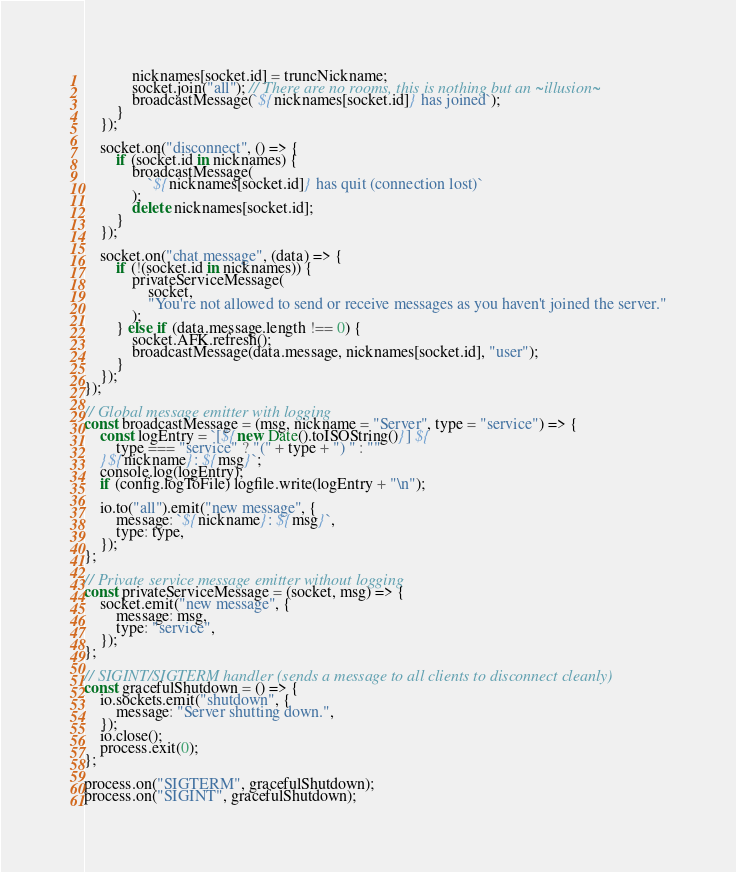Convert code to text. <code><loc_0><loc_0><loc_500><loc_500><_JavaScript_>            nicknames[socket.id] = truncNickname;
            socket.join("all"); // There are no rooms, this is nothing but an ~illusion~
            broadcastMessage(`${nicknames[socket.id]} has joined`);
        }
    });

    socket.on("disconnect", () => {
        if (socket.id in nicknames) {
            broadcastMessage(
                `${nicknames[socket.id]} has quit (connection lost)`
            );
            delete nicknames[socket.id];
        }
    });

    socket.on("chat message", (data) => {
        if (!(socket.id in nicknames)) {
            privateServiceMessage(
                socket,
                "You're not allowed to send or receive messages as you haven't joined the server."
            );
        } else if (data.message.length !== 0) {
            socket.AFK.refresh();
            broadcastMessage(data.message, nicknames[socket.id], "user");
        }
    });
});

// Global message emitter with logging
const broadcastMessage = (msg, nickname = "Server", type = "service") => {
    const logEntry = `[${new Date().toISOString()}] ${
        type === "service" ? "(" + type + ") " : ""
    }${nickname}: ${msg}`;
    console.log(logEntry);
    if (config.logToFile) logfile.write(logEntry + "\n");

    io.to("all").emit("new message", {
        message: `${nickname}: ${msg}`,
        type: type,
    });
};

// Private service message emitter without logging
const privateServiceMessage = (socket, msg) => {
    socket.emit("new message", {
        message: msg,
        type: "service",
    });
};

// SIGINT/SIGTERM handler (sends a message to all clients to disconnect cleanly)
const gracefulShutdown = () => {
    io.sockets.emit("shutdown", {
        message: "Server shutting down.",
    });
    io.close();
    process.exit(0);
};

process.on("SIGTERM", gracefulShutdown);
process.on("SIGINT", gracefulShutdown);
</code> 